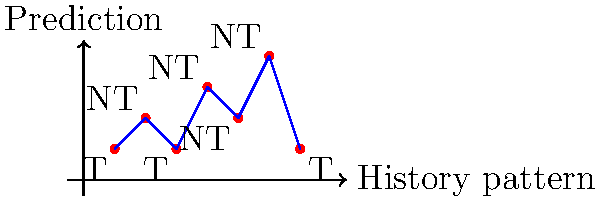You're branching out into a new predictor design! Given the branch history pattern shown in the graph, where T represents Taken and NT represents Not Taken, what would be the accuracy of a 1-bit predictor that starts with an initial prediction of Taken? Let's break this down step-by-step:

1) A 1-bit predictor has two states: Predict Taken (T) or Predict Not Taken (NT).
2) It starts predicting T and only changes its prediction after a misprediction.
3) Let's go through the history pattern:
   - Start: Predict T
   - 1st branch: Actual T, Prediction T - Correct
   - 2nd branch: Actual NT, Prediction T - Incorrect, switch to NT
   - 3rd branch: Actual T, Prediction NT - Incorrect, switch to T
   - 4th branch: Actual NT, Prediction T - Incorrect, switch to NT
   - 5th branch: Actual NT, Prediction NT - Correct
   - 6th branch: Actual NT, Prediction NT - Correct
   - 7th branch: Actual T, Prediction NT - Incorrect

4) Count correct predictions: 3 out of 7 branches were predicted correctly.
5) Calculate accuracy: $\frac{3}{7} \approx 0.4286$ or about 42.86%

This predictor's performance is a bit like a bad pun - it misses more often than it hits!
Answer: 42.86% 